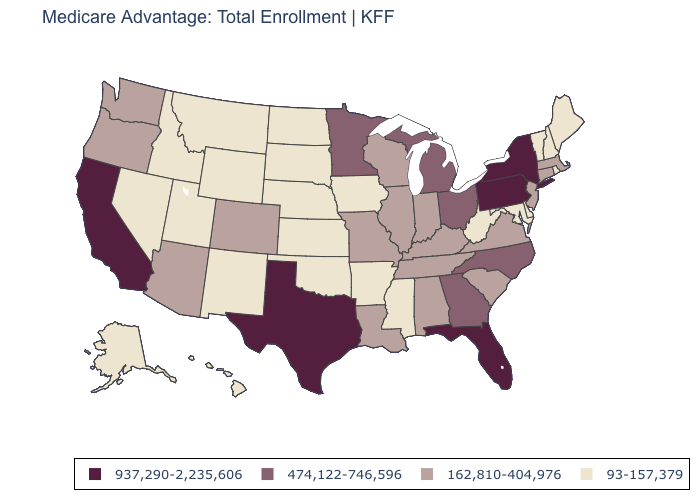Name the states that have a value in the range 937,290-2,235,606?
Give a very brief answer. California, Florida, New York, Pennsylvania, Texas. Is the legend a continuous bar?
Be succinct. No. Name the states that have a value in the range 93-157,379?
Quick response, please. Alaska, Arkansas, Delaware, Hawaii, Iowa, Idaho, Kansas, Maryland, Maine, Mississippi, Montana, North Dakota, Nebraska, New Hampshire, New Mexico, Nevada, Oklahoma, Rhode Island, South Dakota, Utah, Vermont, West Virginia, Wyoming. Does the map have missing data?
Give a very brief answer. No. What is the lowest value in the West?
Write a very short answer. 93-157,379. What is the value of Vermont?
Write a very short answer. 93-157,379. Name the states that have a value in the range 162,810-404,976?
Keep it brief. Alabama, Arizona, Colorado, Connecticut, Illinois, Indiana, Kentucky, Louisiana, Massachusetts, Missouri, New Jersey, Oregon, South Carolina, Tennessee, Virginia, Washington, Wisconsin. How many symbols are there in the legend?
Concise answer only. 4. What is the value of Wyoming?
Answer briefly. 93-157,379. How many symbols are there in the legend?
Give a very brief answer. 4. Name the states that have a value in the range 162,810-404,976?
Answer briefly. Alabama, Arizona, Colorado, Connecticut, Illinois, Indiana, Kentucky, Louisiana, Massachusetts, Missouri, New Jersey, Oregon, South Carolina, Tennessee, Virginia, Washington, Wisconsin. Name the states that have a value in the range 937,290-2,235,606?
Be succinct. California, Florida, New York, Pennsylvania, Texas. Among the states that border Oregon , which have the lowest value?
Concise answer only. Idaho, Nevada. Does North Dakota have the highest value in the MidWest?
Concise answer only. No. What is the value of West Virginia?
Concise answer only. 93-157,379. 